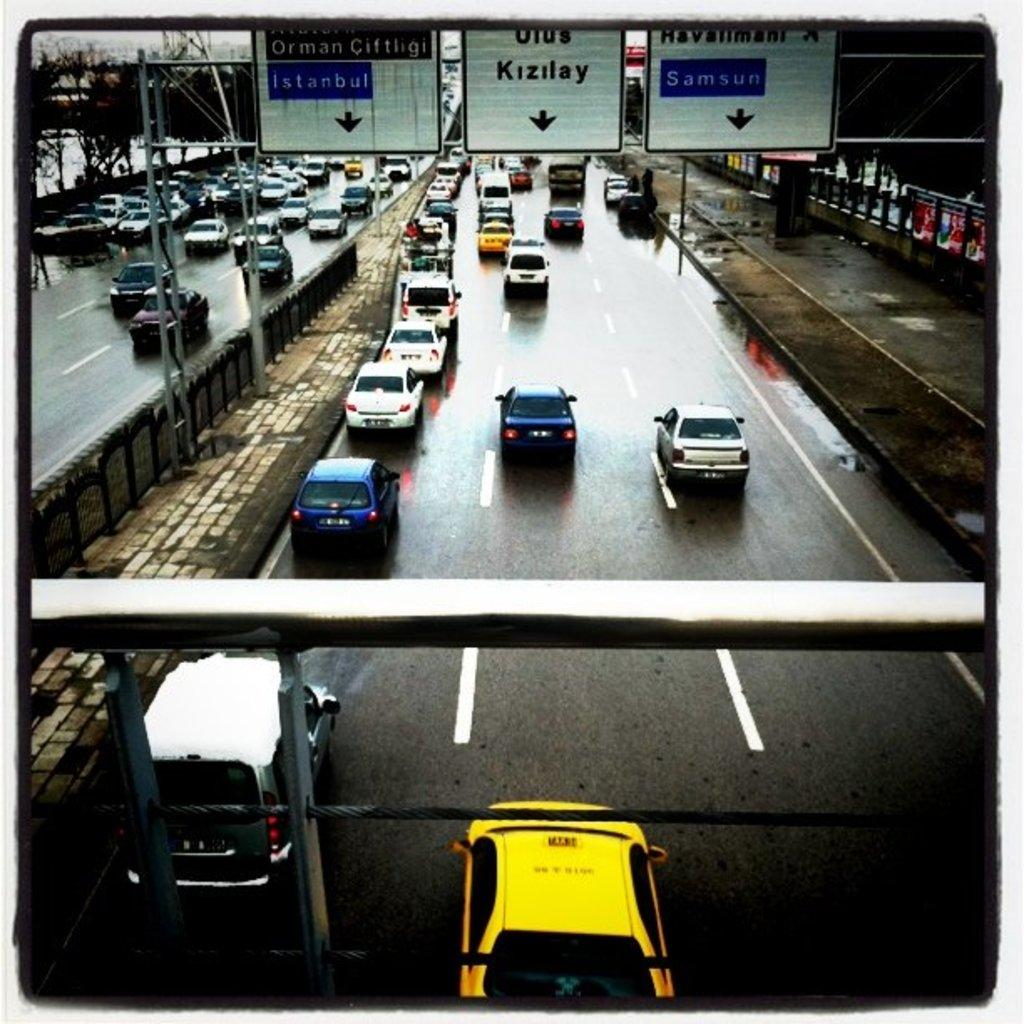<image>
Relay a brief, clear account of the picture shown. A busy freeway has white signs including one that says Kizilay above the traffic. 